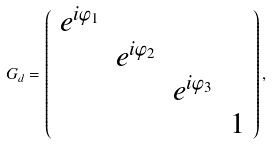<formula> <loc_0><loc_0><loc_500><loc_500>G _ { d } = \left ( \begin{array} { c c c c } e ^ { i \varphi _ { 1 } } \\ & e ^ { i \varphi _ { 2 } } \\ & & e ^ { i \varphi _ { 3 } } \\ & & & 1 \end{array} \right ) ,</formula> 